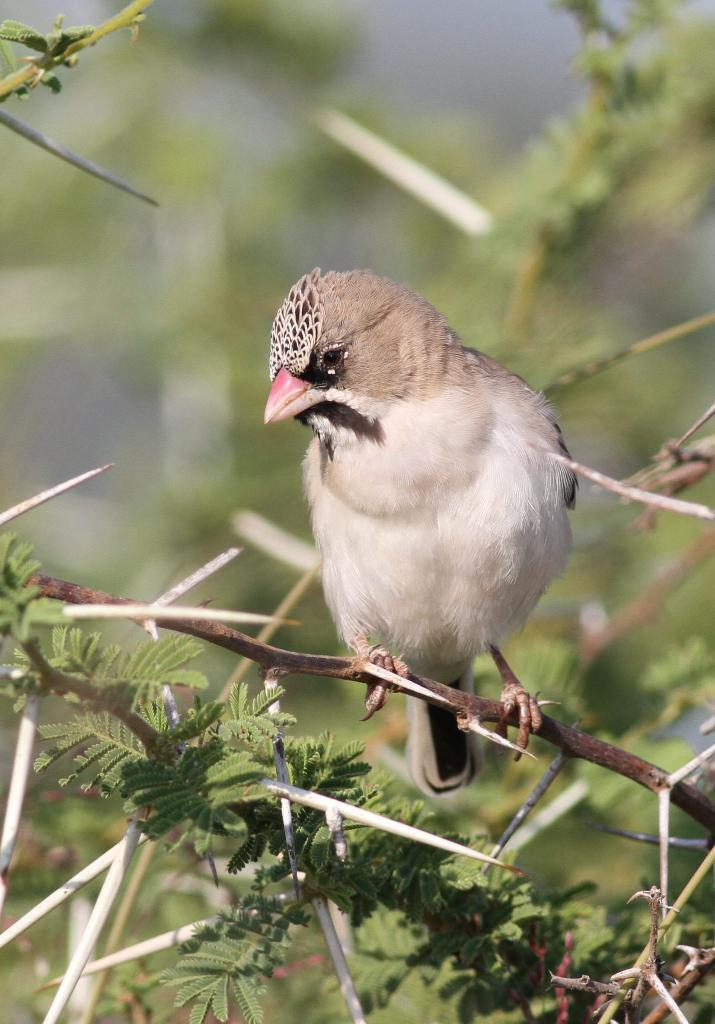What is the main subject in the middle of the image? There is a bird in the middle of the image. What can be seen at the bottom of the image? There are trees at the bottom of the image. What are the thin, elongated structures in the image? There are stems in the image. What are the green, flat structures attached to the stems? There are leaves in the image. What can be seen in the background of the image? There are trees in the background of the image. How many people are sitting on the chair in the image? There is no chair present in the image. What type of seat is the bird using to fly in the image? Birds do not use seats to fly; they have wings that allow them to fly. 